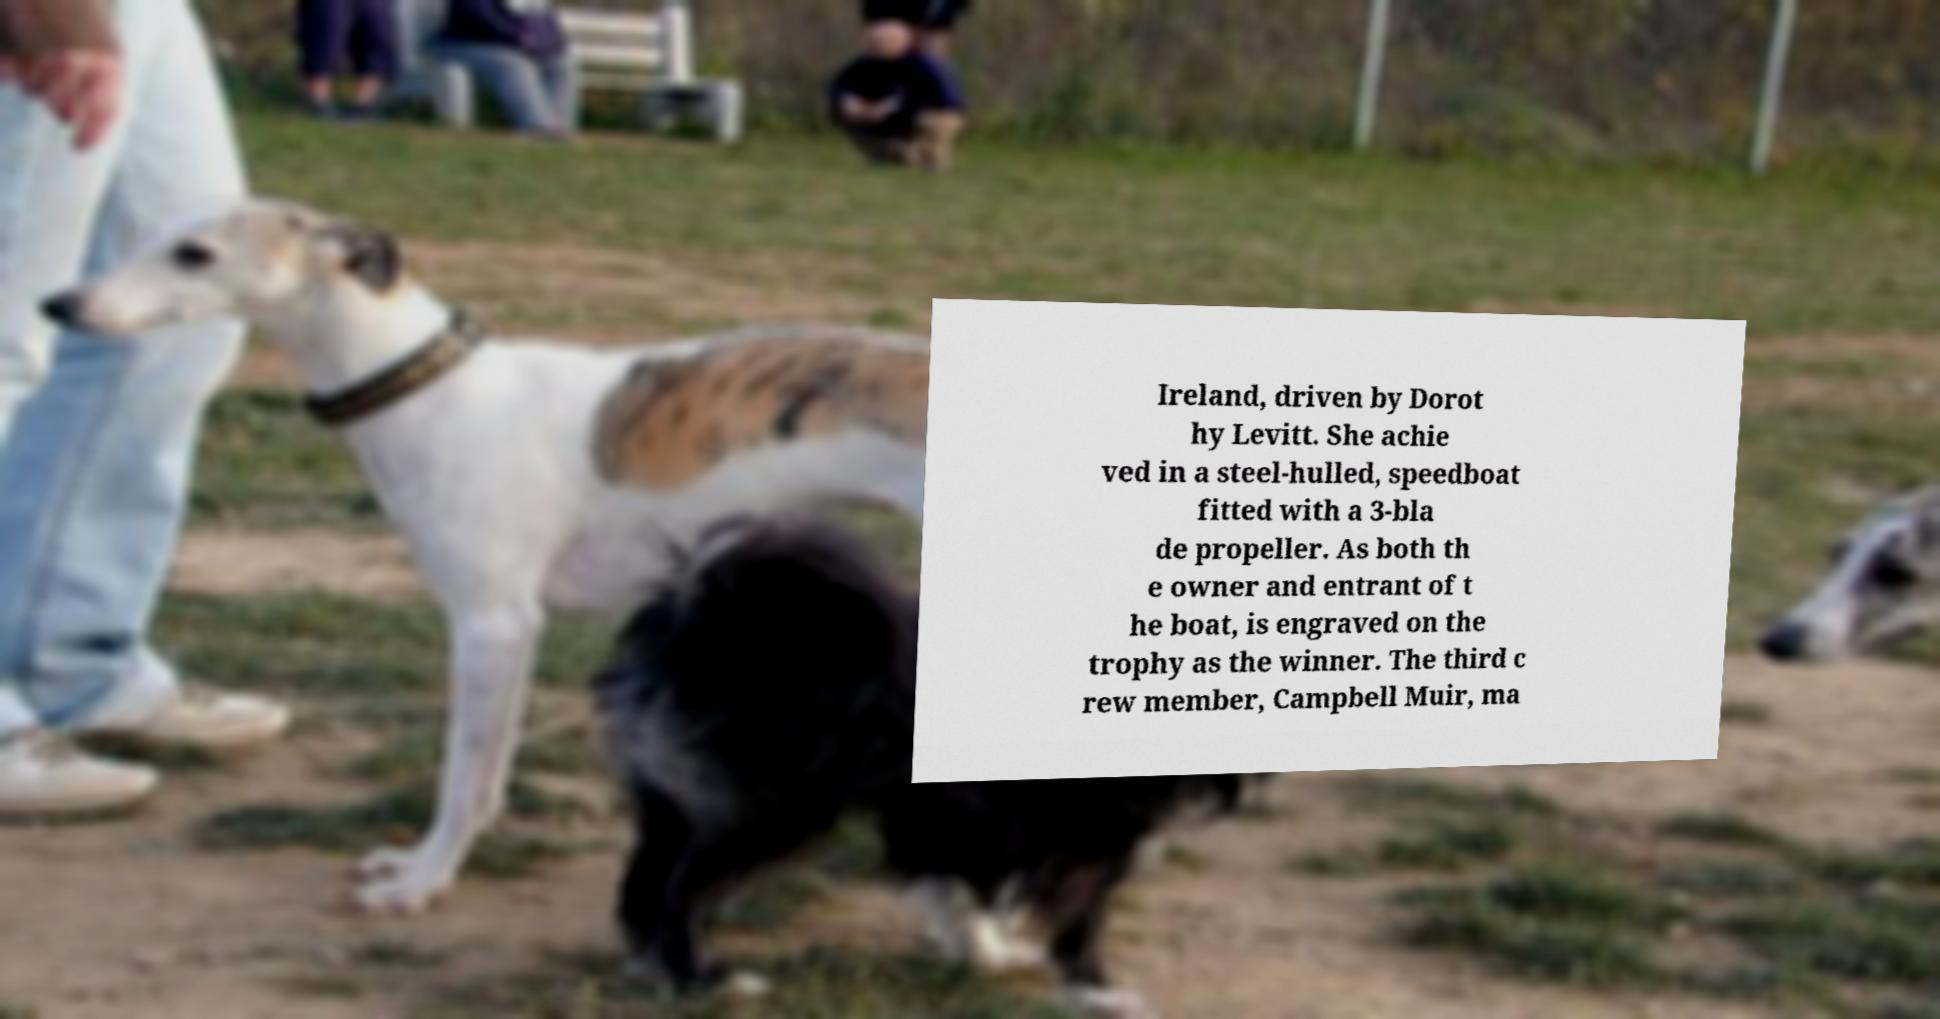Please identify and transcribe the text found in this image. Ireland, driven by Dorot hy Levitt. She achie ved in a steel-hulled, speedboat fitted with a 3-bla de propeller. As both th e owner and entrant of t he boat, is engraved on the trophy as the winner. The third c rew member, Campbell Muir, ma 